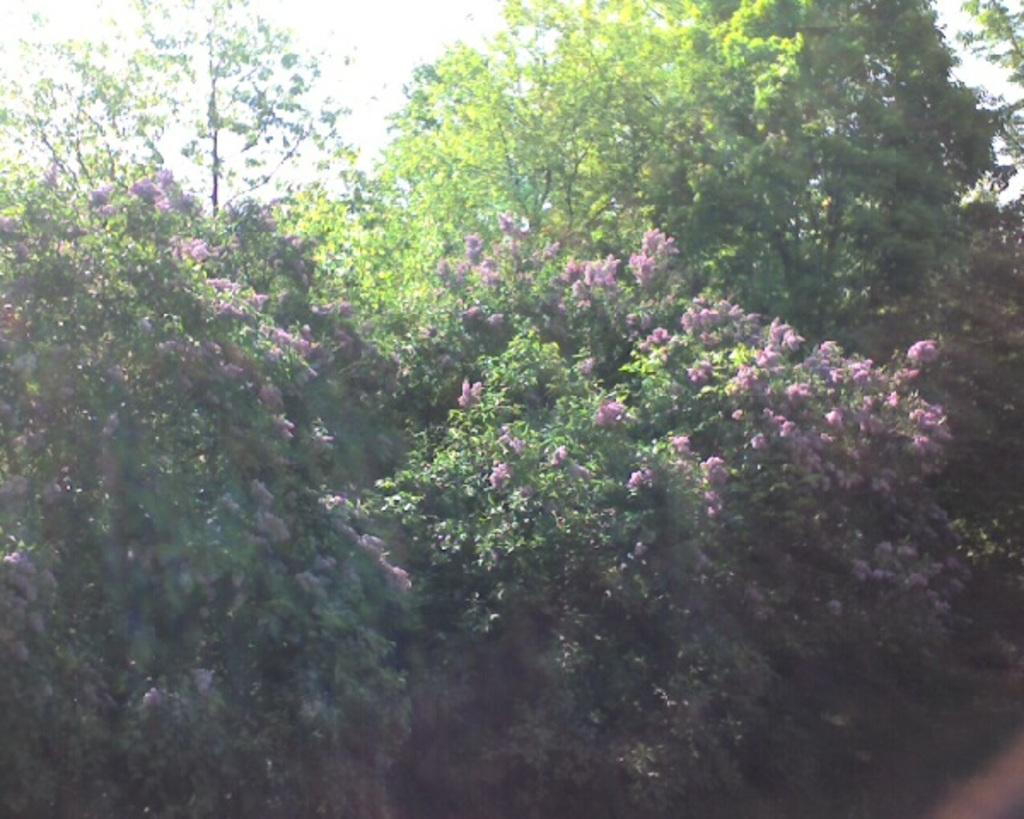What type of living organisms can be seen in the image? Plants can be seen in the image. What additional features are associated with the plants? There are flowers associated with the plants in the image. What is visible at the top of the image? The sky is visible at the top of the image. What type of toys can be seen in the image? There are no toys present in the image. What type of achievement is being celebrated with the bucket in the image? There is no bucket or achievement being celebrated in the image. 